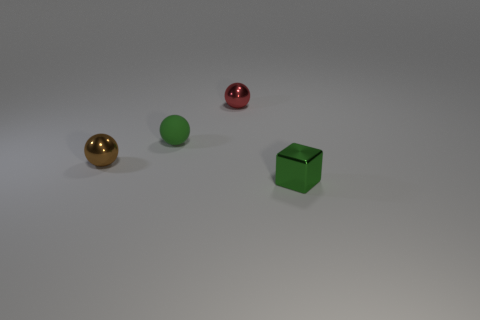Is the material of the small sphere that is behind the small green sphere the same as the brown thing?
Make the answer very short. Yes. What is the color of the tiny object that is both in front of the tiny red object and on the right side of the matte thing?
Provide a succinct answer. Green. What number of tiny brown objects are in front of the green thing behind the small green metal object?
Offer a very short reply. 1. There is a tiny red thing that is the same shape as the brown shiny thing; what is it made of?
Offer a very short reply. Metal. How many objects are balls or metal objects?
Offer a terse response. 4. What is the shape of the metal object that is behind the small object that is left of the tiny rubber sphere?
Keep it short and to the point. Sphere. How many other objects are the same material as the tiny brown ball?
Ensure brevity in your answer.  2. Are the tiny red thing and the small green thing that is left of the red object made of the same material?
Your response must be concise. No. What number of things are either metal things on the left side of the matte thing or spheres to the left of the small rubber sphere?
Keep it short and to the point. 1. Are there more small brown things to the right of the small brown ball than green blocks to the left of the small cube?
Provide a short and direct response. No. 